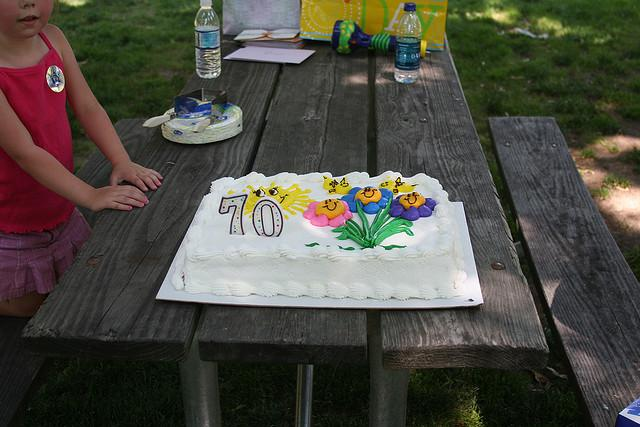What item is drawn on the cake?

Choices:
A) stalactite
B) sun
C) earth
D) moon sun 